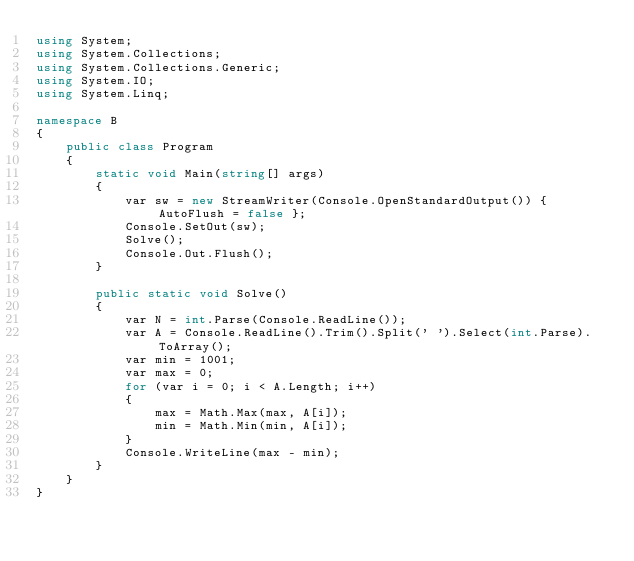Convert code to text. <code><loc_0><loc_0><loc_500><loc_500><_C#_>using System;
using System.Collections;
using System.Collections.Generic;
using System.IO;
using System.Linq;

namespace B
{
    public class Program
    {
        static void Main(string[] args)
        {
            var sw = new StreamWriter(Console.OpenStandardOutput()) { AutoFlush = false };
            Console.SetOut(sw);
            Solve();
            Console.Out.Flush();
        }

        public static void Solve()
        {
            var N = int.Parse(Console.ReadLine());
            var A = Console.ReadLine().Trim().Split(' ').Select(int.Parse).ToArray();
            var min = 1001;
            var max = 0;
            for (var i = 0; i < A.Length; i++)
            {
                max = Math.Max(max, A[i]);
                min = Math.Min(min, A[i]);
            }
            Console.WriteLine(max - min);
        }
    }
}
</code> 